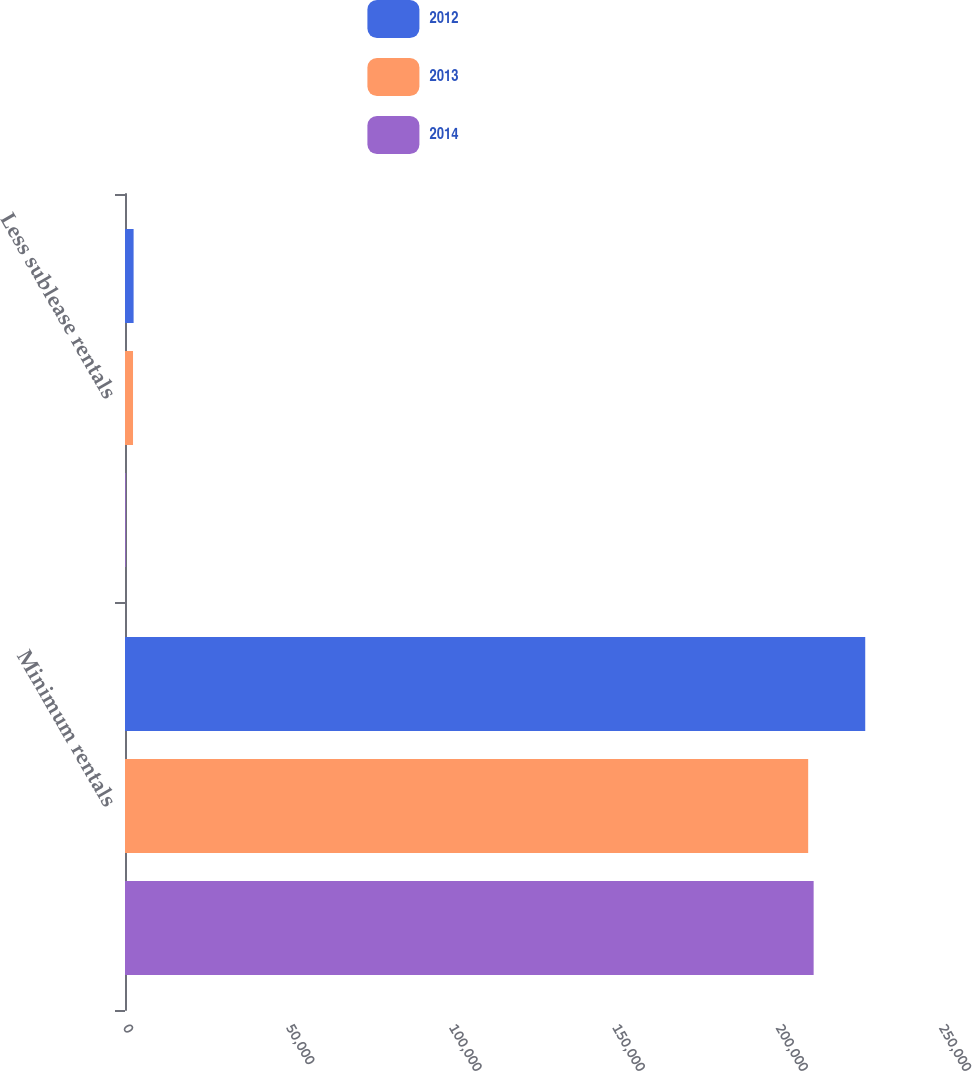<chart> <loc_0><loc_0><loc_500><loc_500><stacked_bar_chart><ecel><fcel>Minimum rentals<fcel>Less sublease rentals<nl><fcel>2012<fcel>226787<fcel>2636<nl><fcel>2013<fcel>209307<fcel>2457<nl><fcel>2014<fcel>210981<fcel>218<nl></chart> 